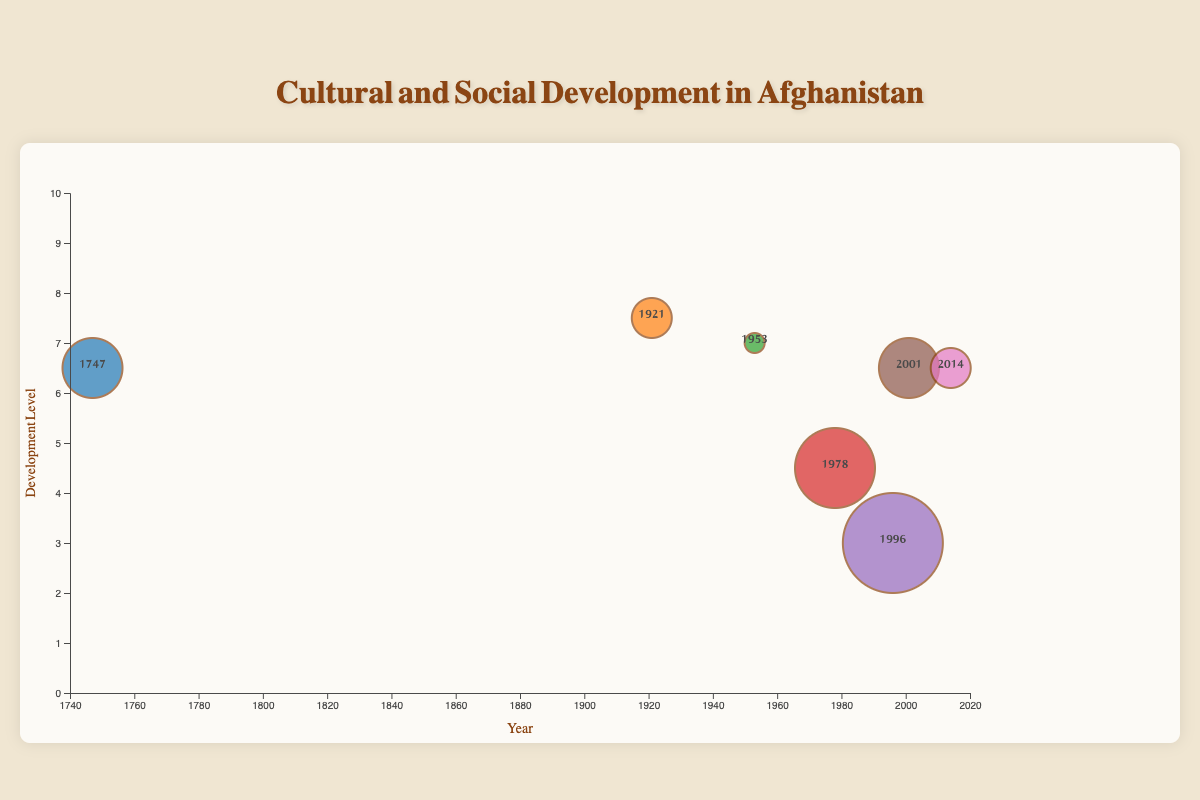What is the title of the figure? The title of the figure is usually located at the top. In this chart, it's written as "Cultural and Social Development in Afghanistan".
Answer: Cultural and Social Development in Afghanistan How many events are displayed in the chart? Each bubble represents one event. By counting the bubbles, we can determine there are 7 events.
Answer: 7 Which event had the highest impact? The size of the bubbles corresponds to the impact value. The largest bubble represents the event with the highest impact, which is the Taliban Takeover in 1996 with an impact score of 10.
Answer: Taliban Takeover What is the approximate cultural development level for the event in 2001? By locating the bubble for the year 2001, we can see it is positioned around a cultural development level of 6.
Answer: 6 Which event resulted in the highest social development score? By inspecting the vertical positions of the bubbles (higher means greater social development), the Anglo-Afghan Treaty in 1921 has the highest social development with a score of 7.
Answer: Anglo-Afghan Treaty Compare the average cultural and social development scores for the Foundation of Modern Afghanistan (1747) and the Presidential Election (2014). Which one is higher? Calculate the average for both: 1747 (cultural: 7, social: 6) averages to (7+6)/2 = 6.5, while 2014 (cultural: 7, social: 6) averages to (7+6)/2 = 6.5. The averages are equal.
Answer: Equal Which event had the lowest cultural development score? By observing the vertical position of each bubble and the color-coded information, the Taliban Takeover in 1996 has the lowest cultural development score of 3.
Answer: Taliban Takeover What is the trend in social development scores from 1921 to 2001? Review the social development scores chronologically: 1921 (7), 1953 (7), 1978 (4), 1996 (3), 2001 (7). The trend shows an initial stability, then a decline from 1978 to 1996, followed by an increase in 2001.
Answer: Decrease and increase How did the Saur Revolution in 1978 impact cultural development compared to the Rise of Daoud Khan in 1953? Compare the cultural development scores: 1978 has a cultural development score of 5, while 1953 has a score of 7. Saur Revolution has a lower score than Rise of Daoud Khan.
Answer: Lower What is the approximate average development level (combining cultural and social development) for the events in 1996 and 2001? Calculate the combined average for both: 1996 (cultural: 3, social: 3) averages to (3+3)/2 = 3, and 2001 (cultural: 6, social: 7) averages to (6+7)/2 = 6.5. Average these two: (3+6.5)/2 = 4.75.
Answer: 4.75 